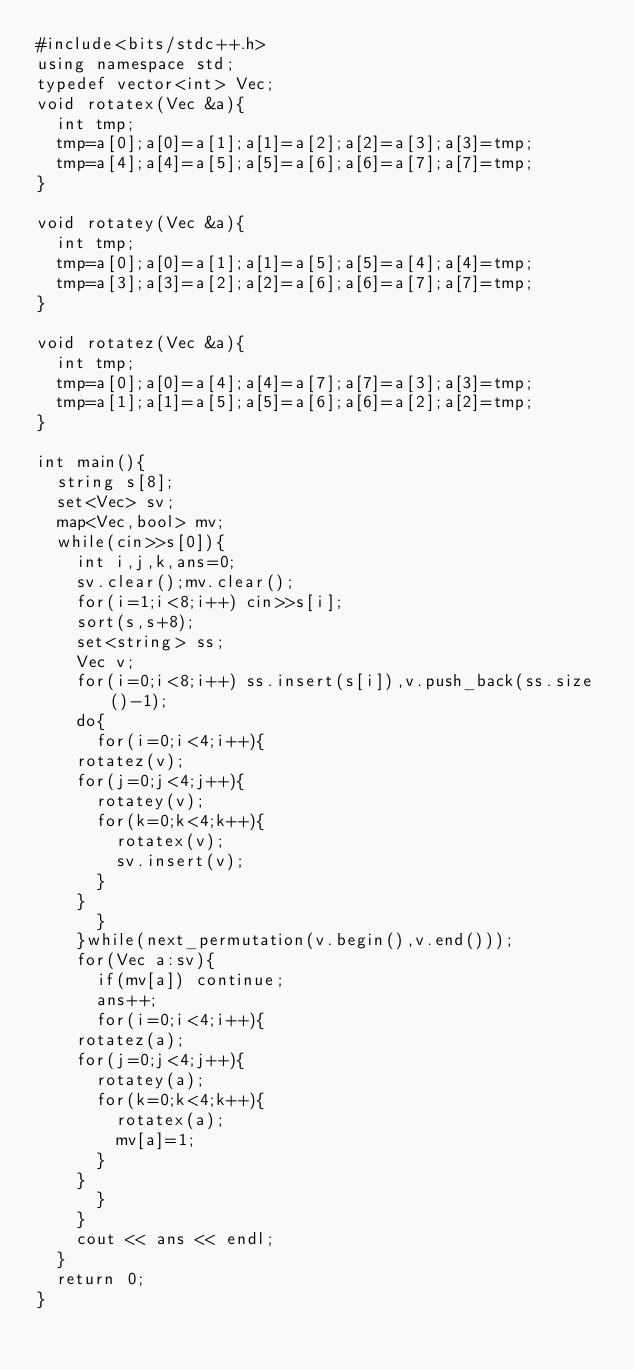<code> <loc_0><loc_0><loc_500><loc_500><_C++_>#include<bits/stdc++.h>
using namespace std;
typedef vector<int> Vec;
void rotatex(Vec &a){
  int tmp;
  tmp=a[0];a[0]=a[1];a[1]=a[2];a[2]=a[3];a[3]=tmp;
  tmp=a[4];a[4]=a[5];a[5]=a[6];a[6]=a[7];a[7]=tmp;
}

void rotatey(Vec &a){
  int tmp;
  tmp=a[0];a[0]=a[1];a[1]=a[5];a[5]=a[4];a[4]=tmp;
  tmp=a[3];a[3]=a[2];a[2]=a[6];a[6]=a[7];a[7]=tmp;
}

void rotatez(Vec &a){
  int tmp;
  tmp=a[0];a[0]=a[4];a[4]=a[7];a[7]=a[3];a[3]=tmp;
  tmp=a[1];a[1]=a[5];a[5]=a[6];a[6]=a[2];a[2]=tmp;
}

int main(){
  string s[8];
  set<Vec> sv;
  map<Vec,bool> mv;
  while(cin>>s[0]){
    int i,j,k,ans=0;
    sv.clear();mv.clear();
    for(i=1;i<8;i++) cin>>s[i];
    sort(s,s+8);
    set<string> ss;
    Vec v;
    for(i=0;i<8;i++) ss.insert(s[i]),v.push_back(ss.size()-1);
    do{
      for(i=0;i<4;i++){
	rotatez(v);
	for(j=0;j<4;j++){
	  rotatey(v);
	  for(k=0;k<4;k++){
	    rotatex(v);
	    sv.insert(v);
	  }
	}
      }
    }while(next_permutation(v.begin(),v.end()));
    for(Vec a:sv){
      if(mv[a]) continue;
      ans++;
      for(i=0;i<4;i++){
	rotatez(a);
	for(j=0;j<4;j++){
	  rotatey(a);
	  for(k=0;k<4;k++){
	    rotatex(a);
	    mv[a]=1;
	  }
	}
      }
    }
    cout << ans << endl;
  }
  return 0;
}</code> 